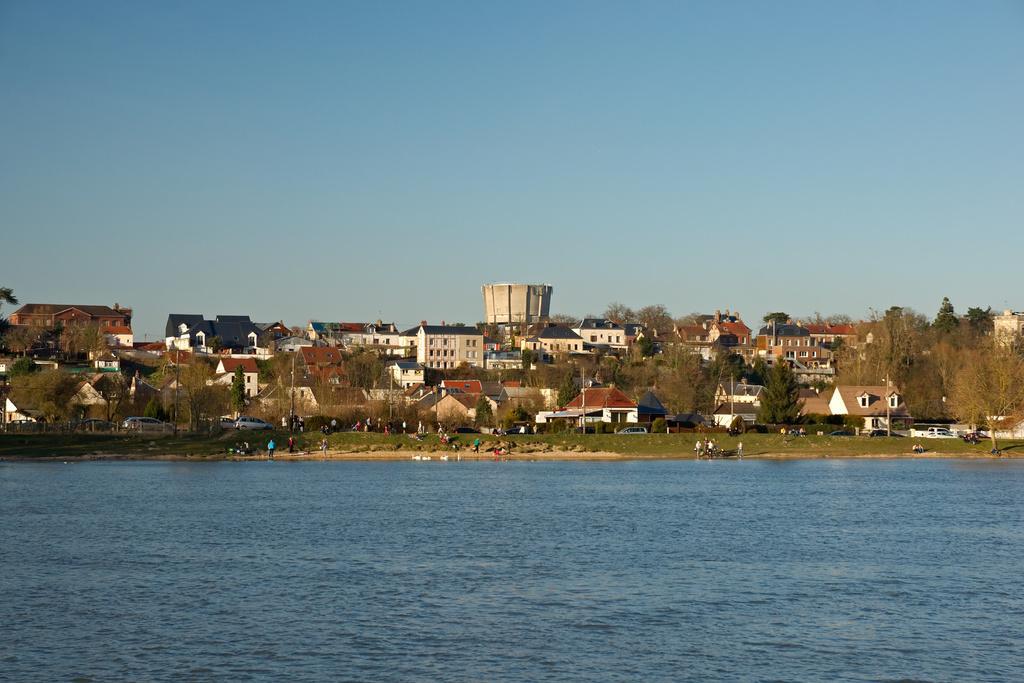Please provide a concise description of this image. In this image we can see water, few people and vehicles on the ground, there are buildings and trees and the sky in the background. 